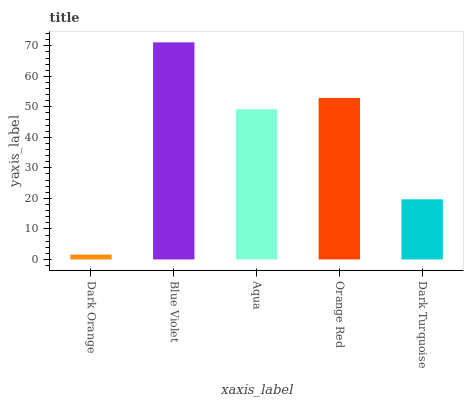Is Dark Orange the minimum?
Answer yes or no. Yes. Is Blue Violet the maximum?
Answer yes or no. Yes. Is Aqua the minimum?
Answer yes or no. No. Is Aqua the maximum?
Answer yes or no. No. Is Blue Violet greater than Aqua?
Answer yes or no. Yes. Is Aqua less than Blue Violet?
Answer yes or no. Yes. Is Aqua greater than Blue Violet?
Answer yes or no. No. Is Blue Violet less than Aqua?
Answer yes or no. No. Is Aqua the high median?
Answer yes or no. Yes. Is Aqua the low median?
Answer yes or no. Yes. Is Dark Turquoise the high median?
Answer yes or no. No. Is Blue Violet the low median?
Answer yes or no. No. 